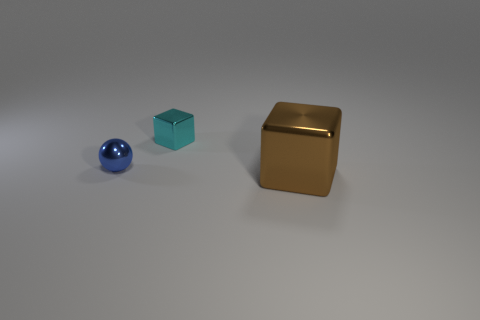Do the small metal object behind the small ball and the large thing have the same shape?
Offer a very short reply. Yes. What is the brown cube made of?
Make the answer very short. Metal. What is the shape of the object right of the cube that is to the left of the block in front of the tiny blue object?
Give a very brief answer. Cube. What number of other things are the same shape as the tiny cyan thing?
Offer a very short reply. 1. There is a large block; is it the same color as the small metallic object in front of the cyan object?
Make the answer very short. No. What number of metallic cubes are there?
Your answer should be compact. 2. What number of things are either small spheres or metal objects?
Your answer should be compact. 3. There is a cyan thing; are there any blue objects in front of it?
Provide a succinct answer. Yes. Are there more tiny blue objects to the left of the small metal block than cyan blocks in front of the large metal cube?
Provide a succinct answer. Yes. There is a cyan shiny object that is the same shape as the brown thing; what is its size?
Your response must be concise. Small. 